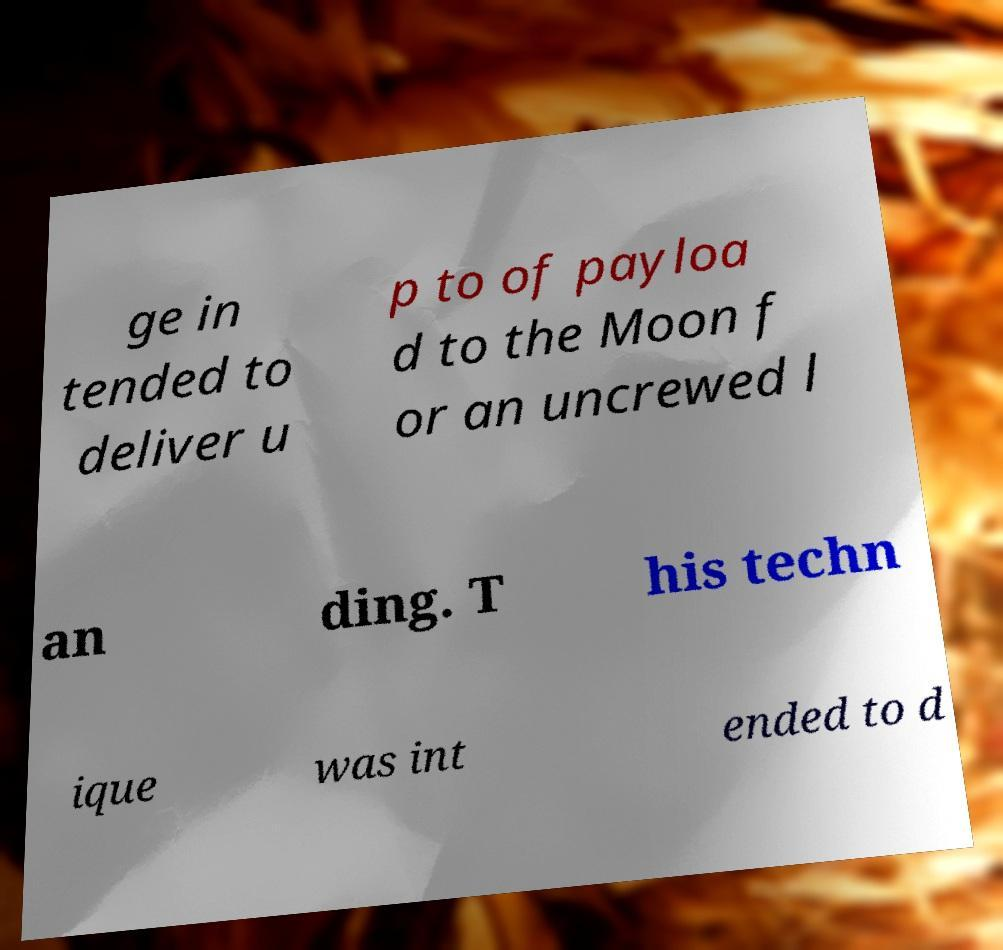Can you accurately transcribe the text from the provided image for me? ge in tended to deliver u p to of payloa d to the Moon f or an uncrewed l an ding. T his techn ique was int ended to d 